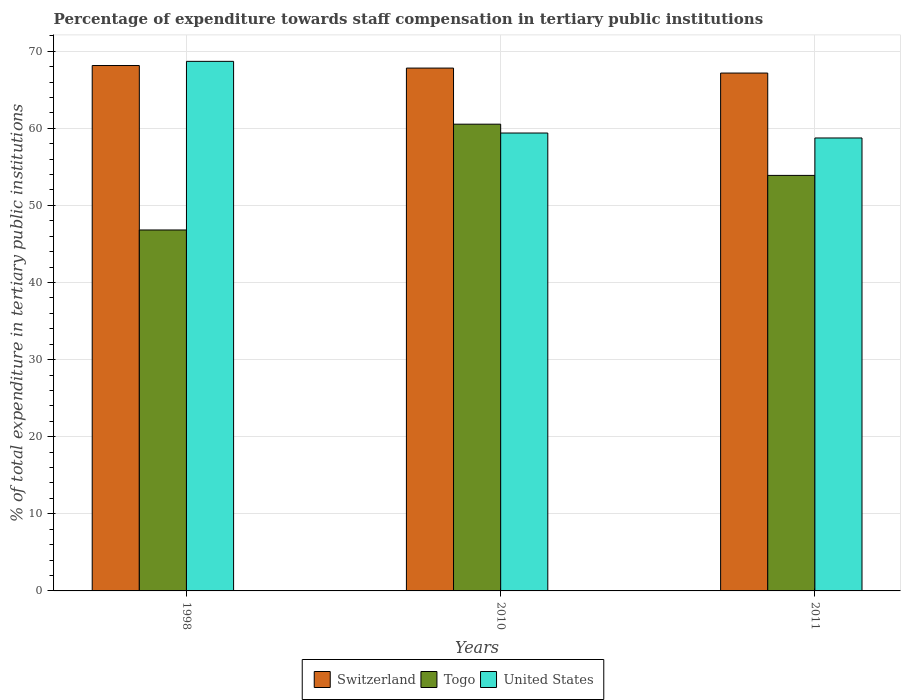How many groups of bars are there?
Keep it short and to the point. 3. Are the number of bars per tick equal to the number of legend labels?
Make the answer very short. Yes. How many bars are there on the 1st tick from the left?
Your answer should be compact. 3. How many bars are there on the 1st tick from the right?
Give a very brief answer. 3. In how many cases, is the number of bars for a given year not equal to the number of legend labels?
Your response must be concise. 0. What is the percentage of expenditure towards staff compensation in Togo in 2011?
Provide a short and direct response. 53.89. Across all years, what is the maximum percentage of expenditure towards staff compensation in United States?
Your response must be concise. 68.68. Across all years, what is the minimum percentage of expenditure towards staff compensation in Switzerland?
Make the answer very short. 67.16. In which year was the percentage of expenditure towards staff compensation in Switzerland minimum?
Ensure brevity in your answer.  2011. What is the total percentage of expenditure towards staff compensation in Togo in the graph?
Make the answer very short. 161.23. What is the difference between the percentage of expenditure towards staff compensation in Togo in 1998 and that in 2010?
Provide a short and direct response. -13.72. What is the difference between the percentage of expenditure towards staff compensation in Togo in 2010 and the percentage of expenditure towards staff compensation in Switzerland in 1998?
Provide a succinct answer. -7.61. What is the average percentage of expenditure towards staff compensation in United States per year?
Provide a succinct answer. 62.27. In the year 2010, what is the difference between the percentage of expenditure towards staff compensation in Togo and percentage of expenditure towards staff compensation in United States?
Keep it short and to the point. 1.15. What is the ratio of the percentage of expenditure towards staff compensation in Togo in 1998 to that in 2010?
Your answer should be very brief. 0.77. Is the percentage of expenditure towards staff compensation in Togo in 2010 less than that in 2011?
Provide a short and direct response. No. What is the difference between the highest and the second highest percentage of expenditure towards staff compensation in United States?
Keep it short and to the point. 9.29. What is the difference between the highest and the lowest percentage of expenditure towards staff compensation in Togo?
Make the answer very short. 13.72. Is the sum of the percentage of expenditure towards staff compensation in Switzerland in 1998 and 2010 greater than the maximum percentage of expenditure towards staff compensation in Togo across all years?
Offer a terse response. Yes. What does the 3rd bar from the left in 2010 represents?
Your answer should be compact. United States. What does the 1st bar from the right in 1998 represents?
Offer a terse response. United States. What is the difference between two consecutive major ticks on the Y-axis?
Offer a terse response. 10. Where does the legend appear in the graph?
Your answer should be compact. Bottom center. What is the title of the graph?
Provide a short and direct response. Percentage of expenditure towards staff compensation in tertiary public institutions. Does "France" appear as one of the legend labels in the graph?
Your answer should be very brief. No. What is the label or title of the Y-axis?
Offer a terse response. % of total expenditure in tertiary public institutions. What is the % of total expenditure in tertiary public institutions in Switzerland in 1998?
Give a very brief answer. 68.14. What is the % of total expenditure in tertiary public institutions of Togo in 1998?
Offer a very short reply. 46.81. What is the % of total expenditure in tertiary public institutions in United States in 1998?
Provide a succinct answer. 68.68. What is the % of total expenditure in tertiary public institutions in Switzerland in 2010?
Keep it short and to the point. 67.81. What is the % of total expenditure in tertiary public institutions of Togo in 2010?
Provide a succinct answer. 60.53. What is the % of total expenditure in tertiary public institutions in United States in 2010?
Offer a very short reply. 59.39. What is the % of total expenditure in tertiary public institutions of Switzerland in 2011?
Give a very brief answer. 67.16. What is the % of total expenditure in tertiary public institutions of Togo in 2011?
Offer a very short reply. 53.89. What is the % of total expenditure in tertiary public institutions of United States in 2011?
Your answer should be compact. 58.74. Across all years, what is the maximum % of total expenditure in tertiary public institutions in Switzerland?
Make the answer very short. 68.14. Across all years, what is the maximum % of total expenditure in tertiary public institutions of Togo?
Your answer should be very brief. 60.53. Across all years, what is the maximum % of total expenditure in tertiary public institutions in United States?
Your response must be concise. 68.68. Across all years, what is the minimum % of total expenditure in tertiary public institutions in Switzerland?
Make the answer very short. 67.16. Across all years, what is the minimum % of total expenditure in tertiary public institutions of Togo?
Your response must be concise. 46.81. Across all years, what is the minimum % of total expenditure in tertiary public institutions in United States?
Offer a terse response. 58.74. What is the total % of total expenditure in tertiary public institutions of Switzerland in the graph?
Ensure brevity in your answer.  203.11. What is the total % of total expenditure in tertiary public institutions in Togo in the graph?
Your response must be concise. 161.23. What is the total % of total expenditure in tertiary public institutions in United States in the graph?
Keep it short and to the point. 186.81. What is the difference between the % of total expenditure in tertiary public institutions of Switzerland in 1998 and that in 2010?
Offer a very short reply. 0.33. What is the difference between the % of total expenditure in tertiary public institutions of Togo in 1998 and that in 2010?
Offer a terse response. -13.72. What is the difference between the % of total expenditure in tertiary public institutions of United States in 1998 and that in 2010?
Your answer should be compact. 9.29. What is the difference between the % of total expenditure in tertiary public institutions of Switzerland in 1998 and that in 2011?
Offer a very short reply. 0.98. What is the difference between the % of total expenditure in tertiary public institutions in Togo in 1998 and that in 2011?
Your response must be concise. -7.08. What is the difference between the % of total expenditure in tertiary public institutions in United States in 1998 and that in 2011?
Offer a very short reply. 9.94. What is the difference between the % of total expenditure in tertiary public institutions in Switzerland in 2010 and that in 2011?
Provide a succinct answer. 0.64. What is the difference between the % of total expenditure in tertiary public institutions of Togo in 2010 and that in 2011?
Offer a very short reply. 6.64. What is the difference between the % of total expenditure in tertiary public institutions of United States in 2010 and that in 2011?
Your answer should be very brief. 0.64. What is the difference between the % of total expenditure in tertiary public institutions of Switzerland in 1998 and the % of total expenditure in tertiary public institutions of Togo in 2010?
Offer a very short reply. 7.61. What is the difference between the % of total expenditure in tertiary public institutions in Switzerland in 1998 and the % of total expenditure in tertiary public institutions in United States in 2010?
Your answer should be very brief. 8.75. What is the difference between the % of total expenditure in tertiary public institutions of Togo in 1998 and the % of total expenditure in tertiary public institutions of United States in 2010?
Your answer should be compact. -12.57. What is the difference between the % of total expenditure in tertiary public institutions of Switzerland in 1998 and the % of total expenditure in tertiary public institutions of Togo in 2011?
Your answer should be very brief. 14.25. What is the difference between the % of total expenditure in tertiary public institutions in Switzerland in 1998 and the % of total expenditure in tertiary public institutions in United States in 2011?
Offer a very short reply. 9.4. What is the difference between the % of total expenditure in tertiary public institutions in Togo in 1998 and the % of total expenditure in tertiary public institutions in United States in 2011?
Keep it short and to the point. -11.93. What is the difference between the % of total expenditure in tertiary public institutions in Switzerland in 2010 and the % of total expenditure in tertiary public institutions in Togo in 2011?
Your answer should be compact. 13.92. What is the difference between the % of total expenditure in tertiary public institutions of Switzerland in 2010 and the % of total expenditure in tertiary public institutions of United States in 2011?
Provide a succinct answer. 9.06. What is the difference between the % of total expenditure in tertiary public institutions in Togo in 2010 and the % of total expenditure in tertiary public institutions in United States in 2011?
Offer a very short reply. 1.79. What is the average % of total expenditure in tertiary public institutions in Switzerland per year?
Provide a short and direct response. 67.7. What is the average % of total expenditure in tertiary public institutions in Togo per year?
Your answer should be compact. 53.74. What is the average % of total expenditure in tertiary public institutions of United States per year?
Offer a terse response. 62.27. In the year 1998, what is the difference between the % of total expenditure in tertiary public institutions of Switzerland and % of total expenditure in tertiary public institutions of Togo?
Your answer should be compact. 21.33. In the year 1998, what is the difference between the % of total expenditure in tertiary public institutions in Switzerland and % of total expenditure in tertiary public institutions in United States?
Your response must be concise. -0.54. In the year 1998, what is the difference between the % of total expenditure in tertiary public institutions in Togo and % of total expenditure in tertiary public institutions in United States?
Ensure brevity in your answer.  -21.87. In the year 2010, what is the difference between the % of total expenditure in tertiary public institutions of Switzerland and % of total expenditure in tertiary public institutions of Togo?
Your response must be concise. 7.27. In the year 2010, what is the difference between the % of total expenditure in tertiary public institutions of Switzerland and % of total expenditure in tertiary public institutions of United States?
Offer a very short reply. 8.42. In the year 2010, what is the difference between the % of total expenditure in tertiary public institutions in Togo and % of total expenditure in tertiary public institutions in United States?
Give a very brief answer. 1.15. In the year 2011, what is the difference between the % of total expenditure in tertiary public institutions in Switzerland and % of total expenditure in tertiary public institutions in Togo?
Your answer should be very brief. 13.27. In the year 2011, what is the difference between the % of total expenditure in tertiary public institutions in Switzerland and % of total expenditure in tertiary public institutions in United States?
Provide a short and direct response. 8.42. In the year 2011, what is the difference between the % of total expenditure in tertiary public institutions in Togo and % of total expenditure in tertiary public institutions in United States?
Offer a very short reply. -4.86. What is the ratio of the % of total expenditure in tertiary public institutions of Switzerland in 1998 to that in 2010?
Offer a very short reply. 1. What is the ratio of the % of total expenditure in tertiary public institutions of Togo in 1998 to that in 2010?
Ensure brevity in your answer.  0.77. What is the ratio of the % of total expenditure in tertiary public institutions in United States in 1998 to that in 2010?
Your response must be concise. 1.16. What is the ratio of the % of total expenditure in tertiary public institutions of Switzerland in 1998 to that in 2011?
Your answer should be compact. 1.01. What is the ratio of the % of total expenditure in tertiary public institutions in Togo in 1998 to that in 2011?
Ensure brevity in your answer.  0.87. What is the ratio of the % of total expenditure in tertiary public institutions in United States in 1998 to that in 2011?
Provide a short and direct response. 1.17. What is the ratio of the % of total expenditure in tertiary public institutions of Switzerland in 2010 to that in 2011?
Give a very brief answer. 1.01. What is the ratio of the % of total expenditure in tertiary public institutions of Togo in 2010 to that in 2011?
Provide a succinct answer. 1.12. What is the ratio of the % of total expenditure in tertiary public institutions of United States in 2010 to that in 2011?
Provide a succinct answer. 1.01. What is the difference between the highest and the second highest % of total expenditure in tertiary public institutions in Switzerland?
Your answer should be compact. 0.33. What is the difference between the highest and the second highest % of total expenditure in tertiary public institutions in Togo?
Offer a very short reply. 6.64. What is the difference between the highest and the second highest % of total expenditure in tertiary public institutions in United States?
Provide a short and direct response. 9.29. What is the difference between the highest and the lowest % of total expenditure in tertiary public institutions in Switzerland?
Keep it short and to the point. 0.98. What is the difference between the highest and the lowest % of total expenditure in tertiary public institutions in Togo?
Your answer should be very brief. 13.72. What is the difference between the highest and the lowest % of total expenditure in tertiary public institutions of United States?
Ensure brevity in your answer.  9.94. 